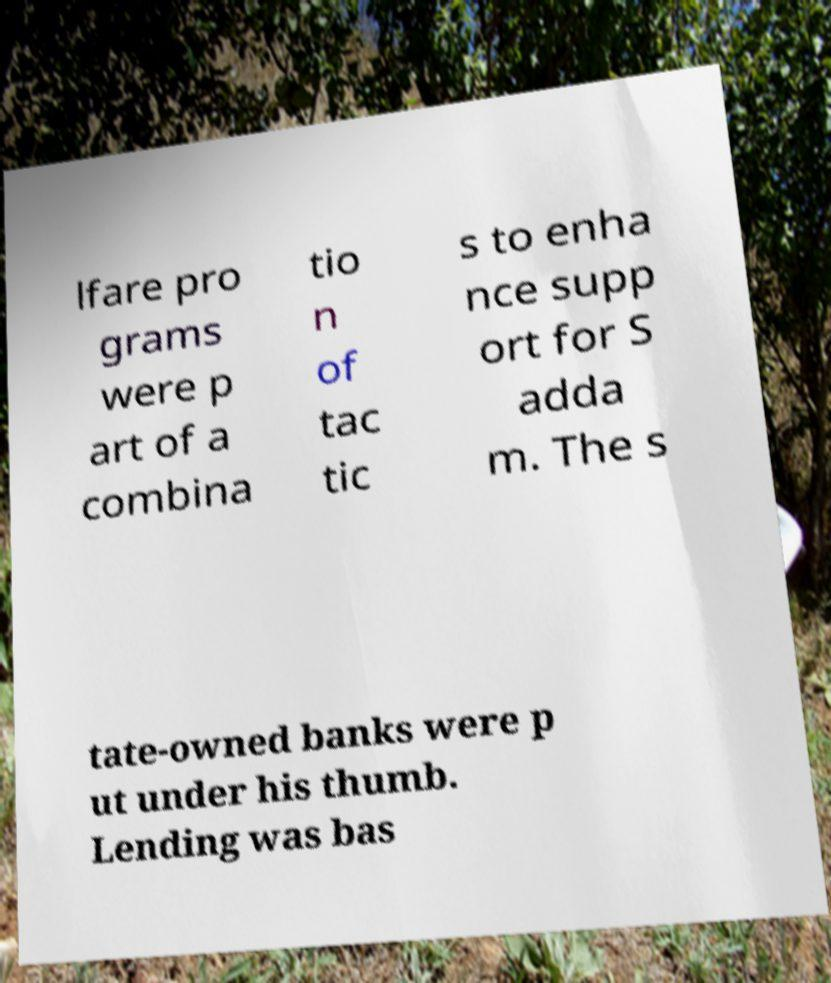Could you extract and type out the text from this image? lfare pro grams were p art of a combina tio n of tac tic s to enha nce supp ort for S adda m. The s tate-owned banks were p ut under his thumb. Lending was bas 